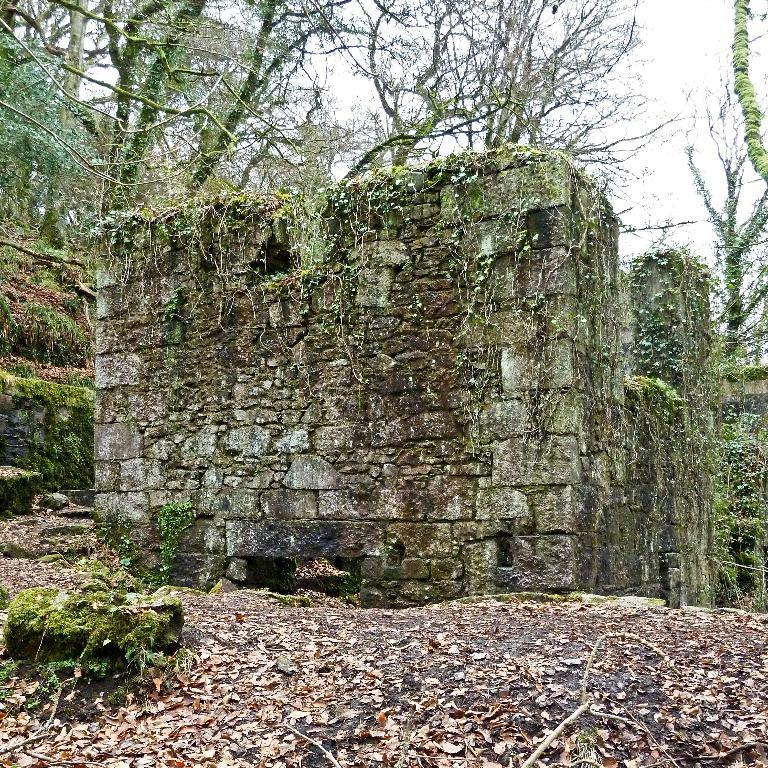What is located in the middle of the image? There is a wall in the middle of the image. What can be seen above the wall in the image? Trees are visible at the top of the image. What is visible in the background of the image? The sky is visible in the background of the image. What advice does the father give in the image? There is no father present in the image, so it is not possible to answer that question. 